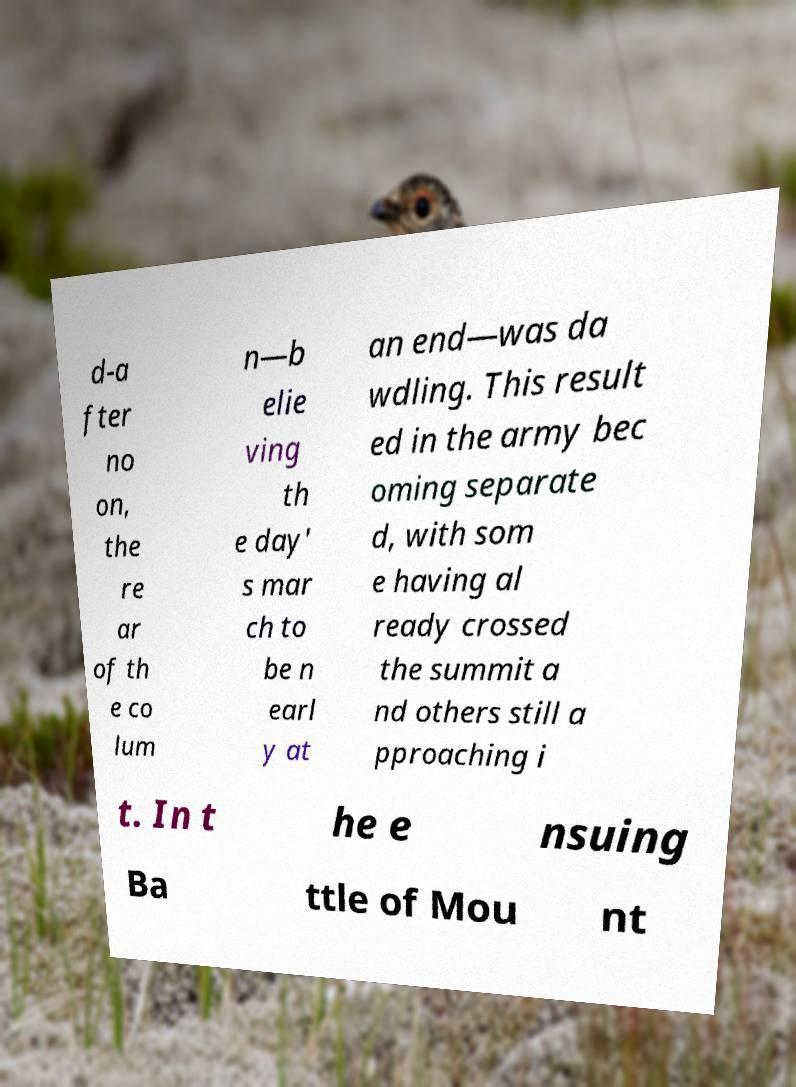What messages or text are displayed in this image? I need them in a readable, typed format. d-a fter no on, the re ar of th e co lum n—b elie ving th e day' s mar ch to be n earl y at an end—was da wdling. This result ed in the army bec oming separate d, with som e having al ready crossed the summit a nd others still a pproaching i t. In t he e nsuing Ba ttle of Mou nt 